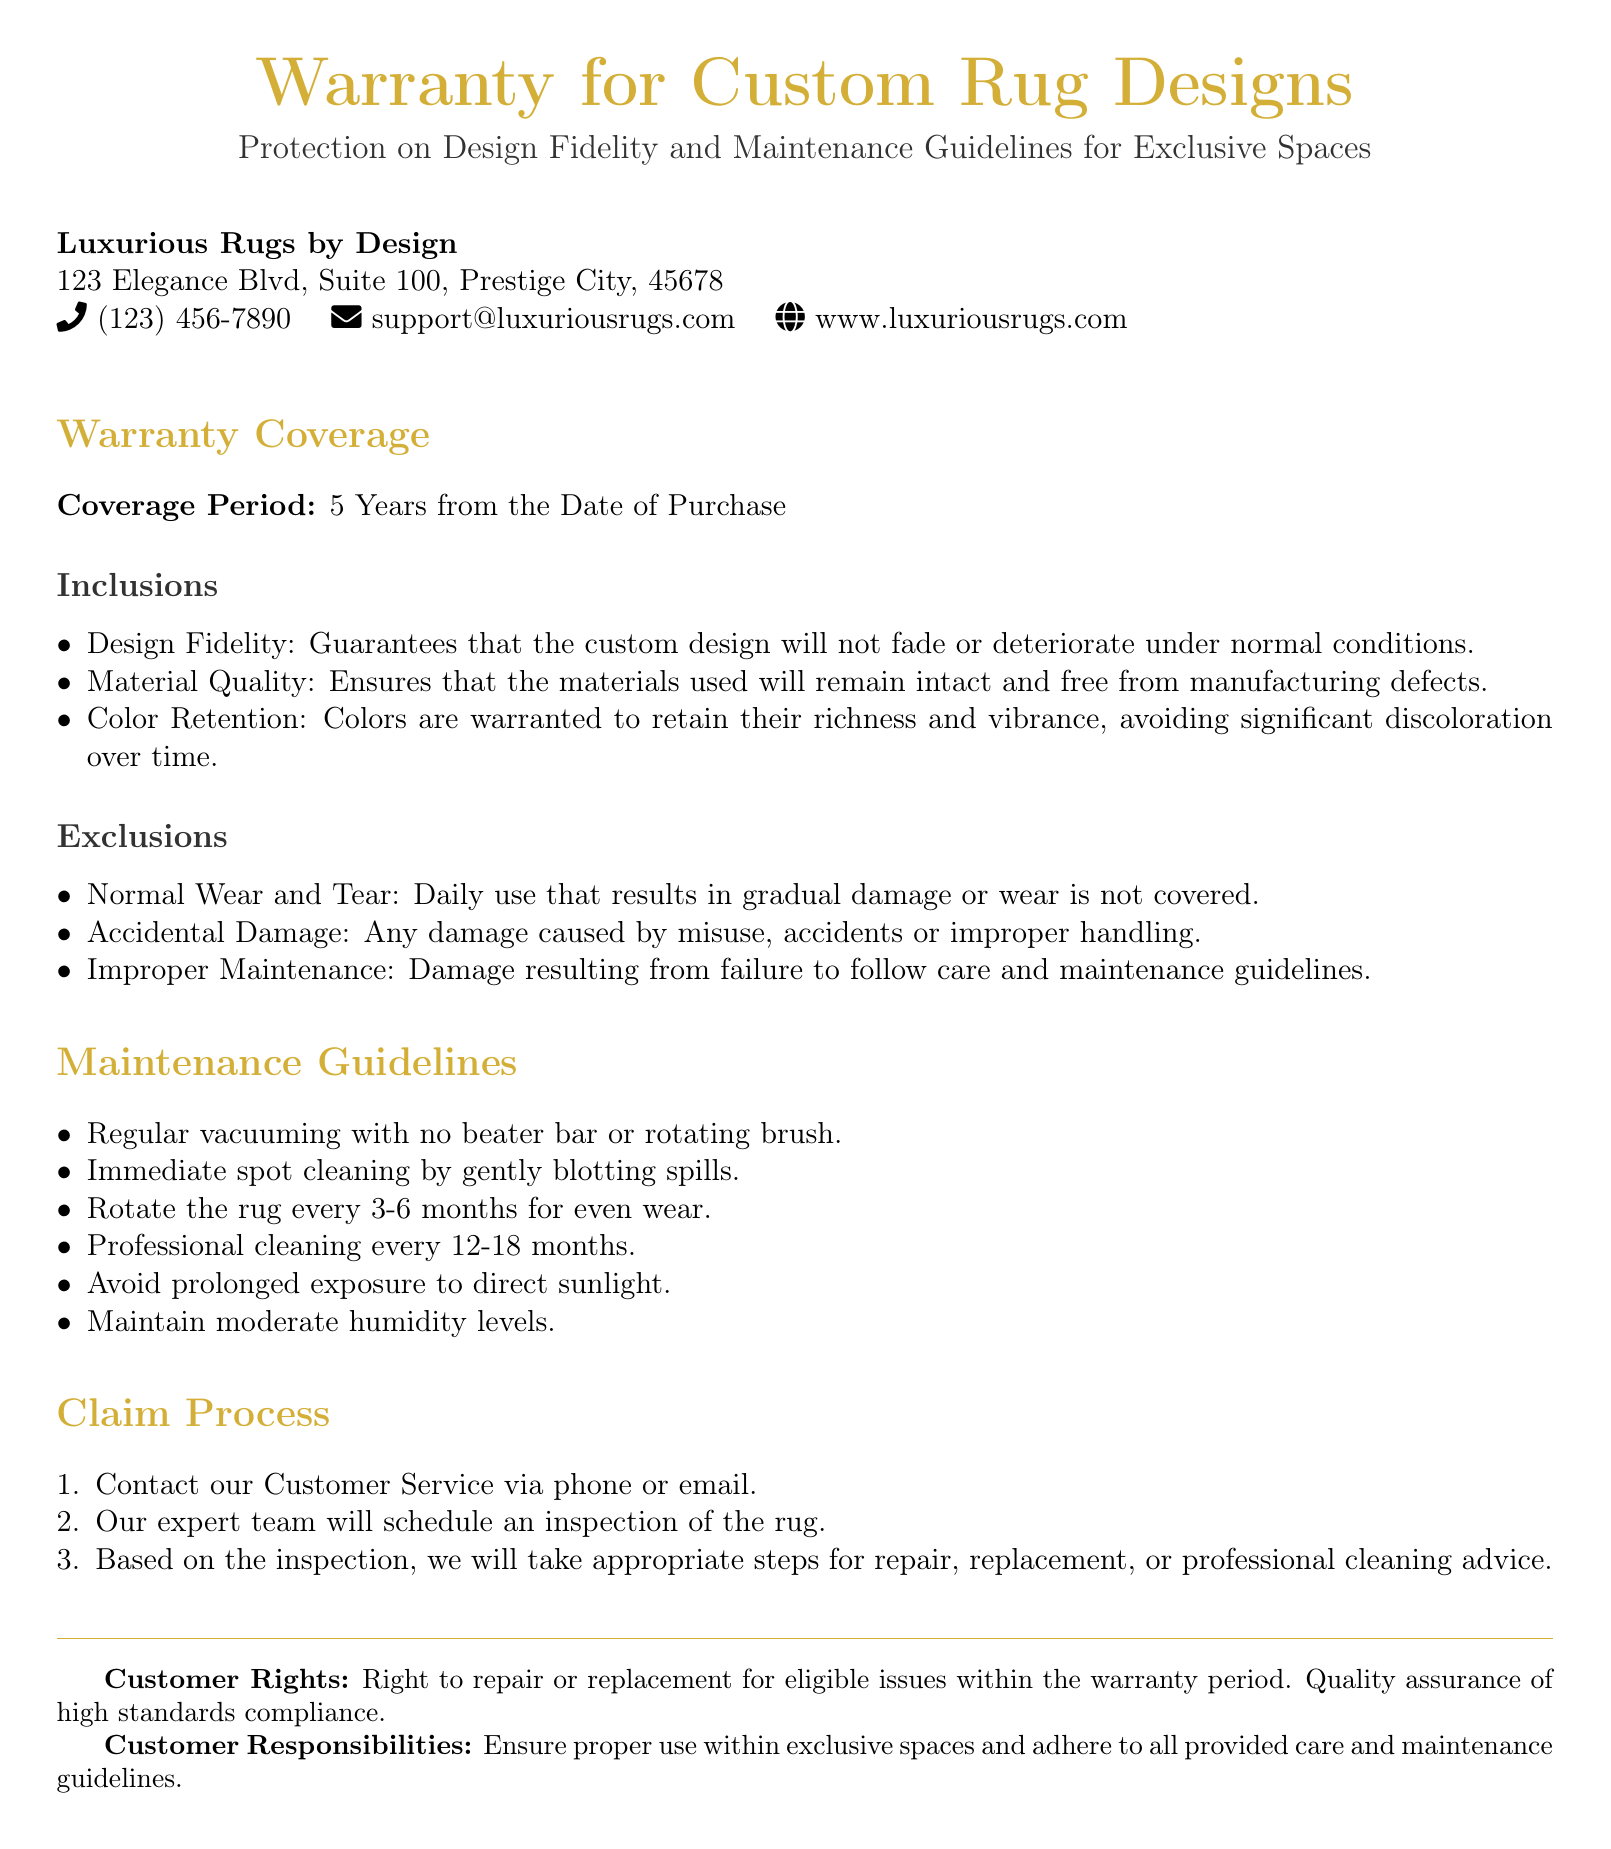What is the coverage period for the warranty? The coverage period is specified in the document and is the duration for which the warranty is valid.
Answer: 5 Years What does the warranty guarantee regarding design fidelity? The warranty includes guarantees about various aspects of the rug, particularly its design.
Answer: Will not fade or deteriorate What should be done to maintain color retention? The maintenance guidelines provide specific instructions for preserving the vibrance of the rug's colors.
Answer: Follow care guidelines What type of damage is considered an exclusion under the warranty? The document outlines specific conditions under which damage is not covered by the warranty.
Answer: Accidental Damage How often should professional cleaning be done? This information is specified in the maintenance guidelines and indicates the frequency of professional upkeep.
Answer: Every 12-18 months What is the first step in the claim process? The claim process provides a sequence of actions that should be taken to file a warranty claim.
Answer: Contact our Customer Service What are customers responsible for under the warranty? The document details the responsibilities that customers must adhere to for warranty coverage.
Answer: Proper use and adherence to care guidelines Which entity created this warranty? The document clearly presents the organization responsible for the warranty and its contact information.
Answer: Luxurious Rugs by Design What is the warranty's stance on normal wear and tear? The document specifies certain exclusions from coverage, including this type of damage.
Answer: Not covered 